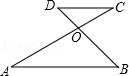Could you explain the significance of the intersection point O in this diagram? Point O represents the intersection of diagonals AC and BD in the geometric figure. Generally, in quadrilaterals bisected by their diagonals, this point can serve as a clue to the properties of the shapes being symmetrical or possessing certain kinds of angles. In parallelogram theory, this point is often the center where diagonals bisect each other, suggesting equal partitioning of the figure or special angle relationships. 